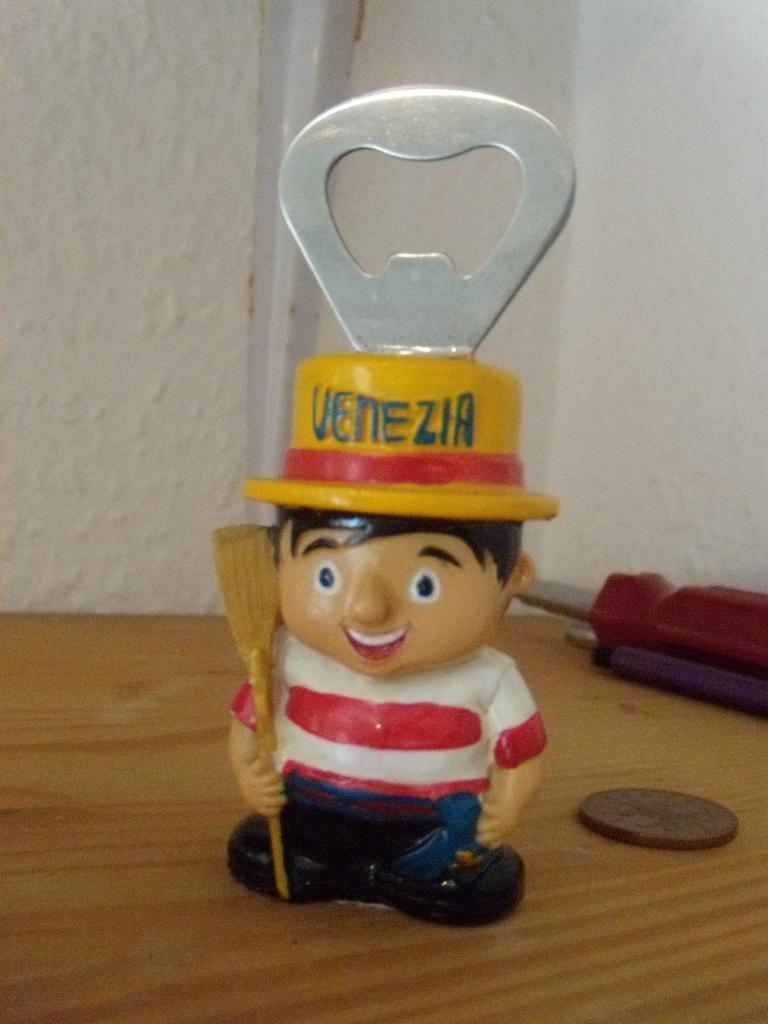Can you describe this image briefly? In this image, we can see an opener screwdriver and coin in front of the wall. 